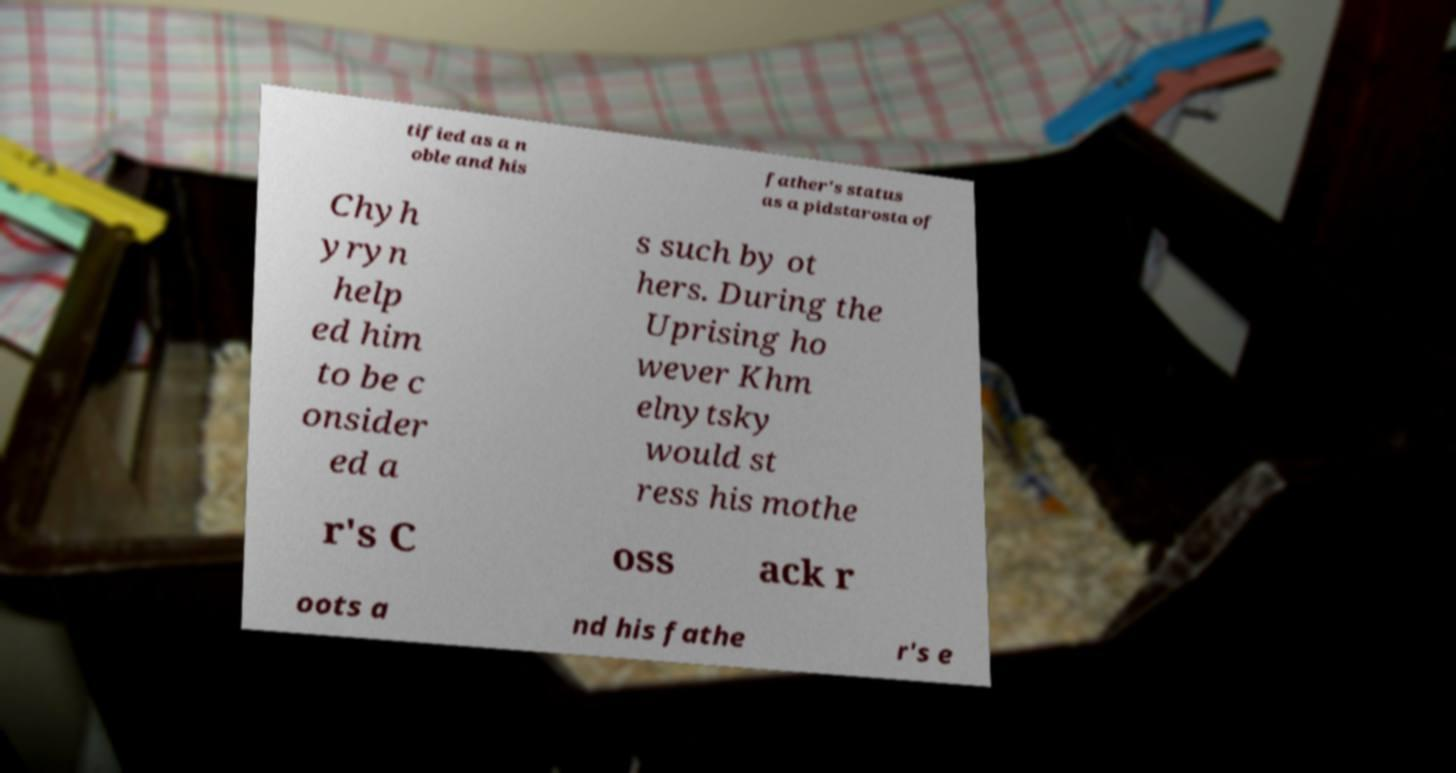Please identify and transcribe the text found in this image. tified as a n oble and his father's status as a pidstarosta of Chyh yryn help ed him to be c onsider ed a s such by ot hers. During the Uprising ho wever Khm elnytsky would st ress his mothe r's C oss ack r oots a nd his fathe r's e 